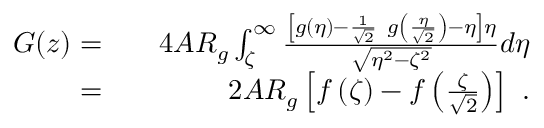<formula> <loc_0><loc_0><loc_500><loc_500>\begin{array} { r l r } { G ( z ) = } & { 4 A R _ { g } \int _ { \zeta } ^ { \infty } \frac { \left [ g ( \eta ) - \frac { 1 } { \sqrt { 2 } } g \left ( \frac { \eta } { \sqrt { 2 } } \right ) - \eta \right ] \eta } { \sqrt { \eta ^ { 2 } - \zeta ^ { 2 } } } d \eta } \\ { = } & { 2 A R _ { g } \left [ f \left ( \zeta \right ) - f \left ( \frac { \zeta } { \sqrt { 2 } } \right ) \right ] . } \end{array}</formula> 